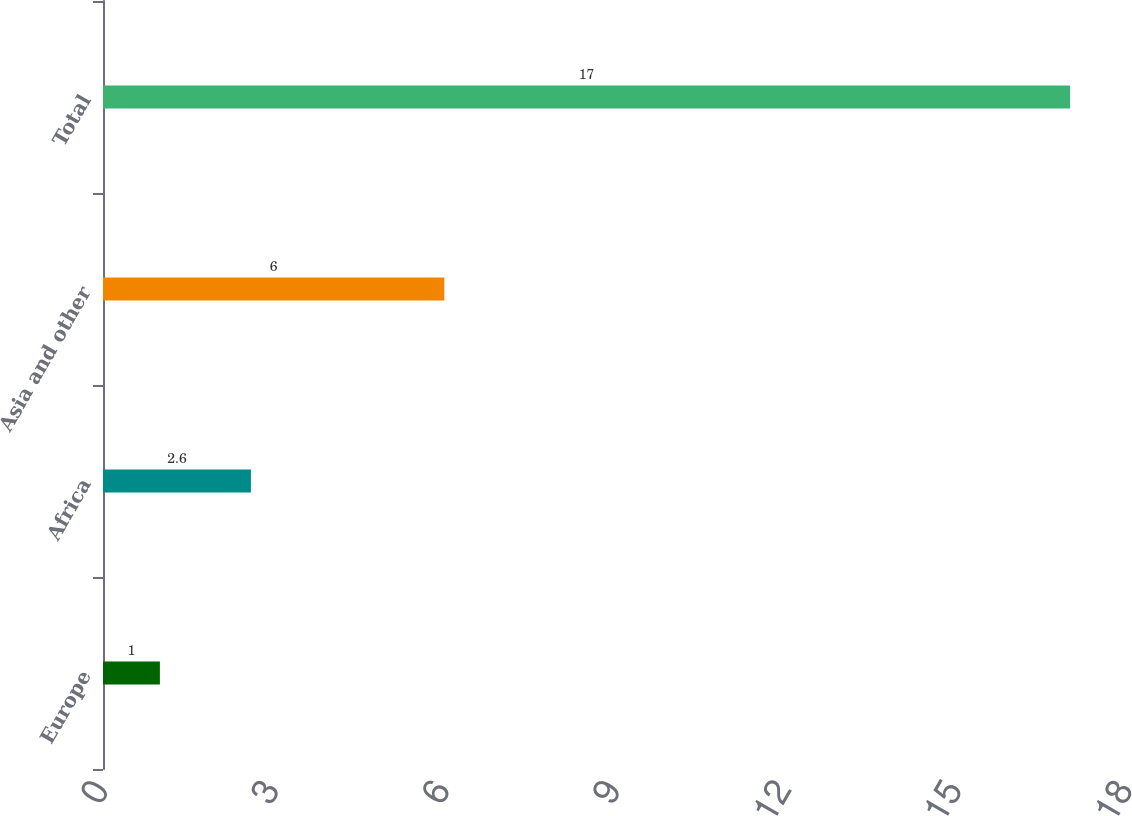Convert chart. <chart><loc_0><loc_0><loc_500><loc_500><bar_chart><fcel>Europe<fcel>Africa<fcel>Asia and other<fcel>Total<nl><fcel>1<fcel>2.6<fcel>6<fcel>17<nl></chart> 